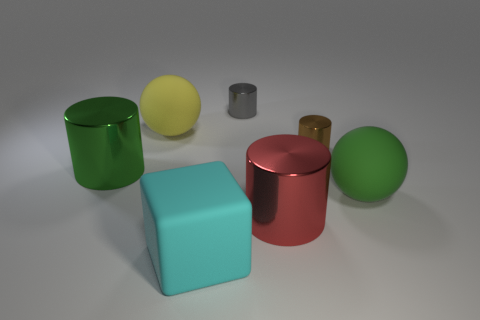What color is the other large metallic thing that is the same shape as the large red metal thing?
Provide a short and direct response. Green. There is a cylinder that is left of the yellow sphere; is it the same size as the green rubber ball?
Your response must be concise. Yes. Are there fewer big green balls that are behind the large cube than big brown rubber cubes?
Your answer should be compact. No. Are there any other things that are the same size as the yellow matte thing?
Your answer should be compact. Yes. There is a green thing to the left of the tiny metal cylinder to the right of the large red shiny thing; what size is it?
Offer a very short reply. Large. Is there anything else that has the same shape as the brown thing?
Offer a terse response. Yes. Are there fewer big shiny objects than big yellow metallic cubes?
Provide a succinct answer. No. The big object that is both behind the red cylinder and to the right of the large cyan object is made of what material?
Provide a short and direct response. Rubber. There is a large green object that is on the right side of the big green metallic thing; are there any gray shiny cylinders on the right side of it?
Give a very brief answer. No. How many things are tiny objects or yellow matte balls?
Your response must be concise. 3. 